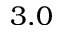Convert formula to latex. <formula><loc_0><loc_0><loc_500><loc_500>3 . 0</formula> 